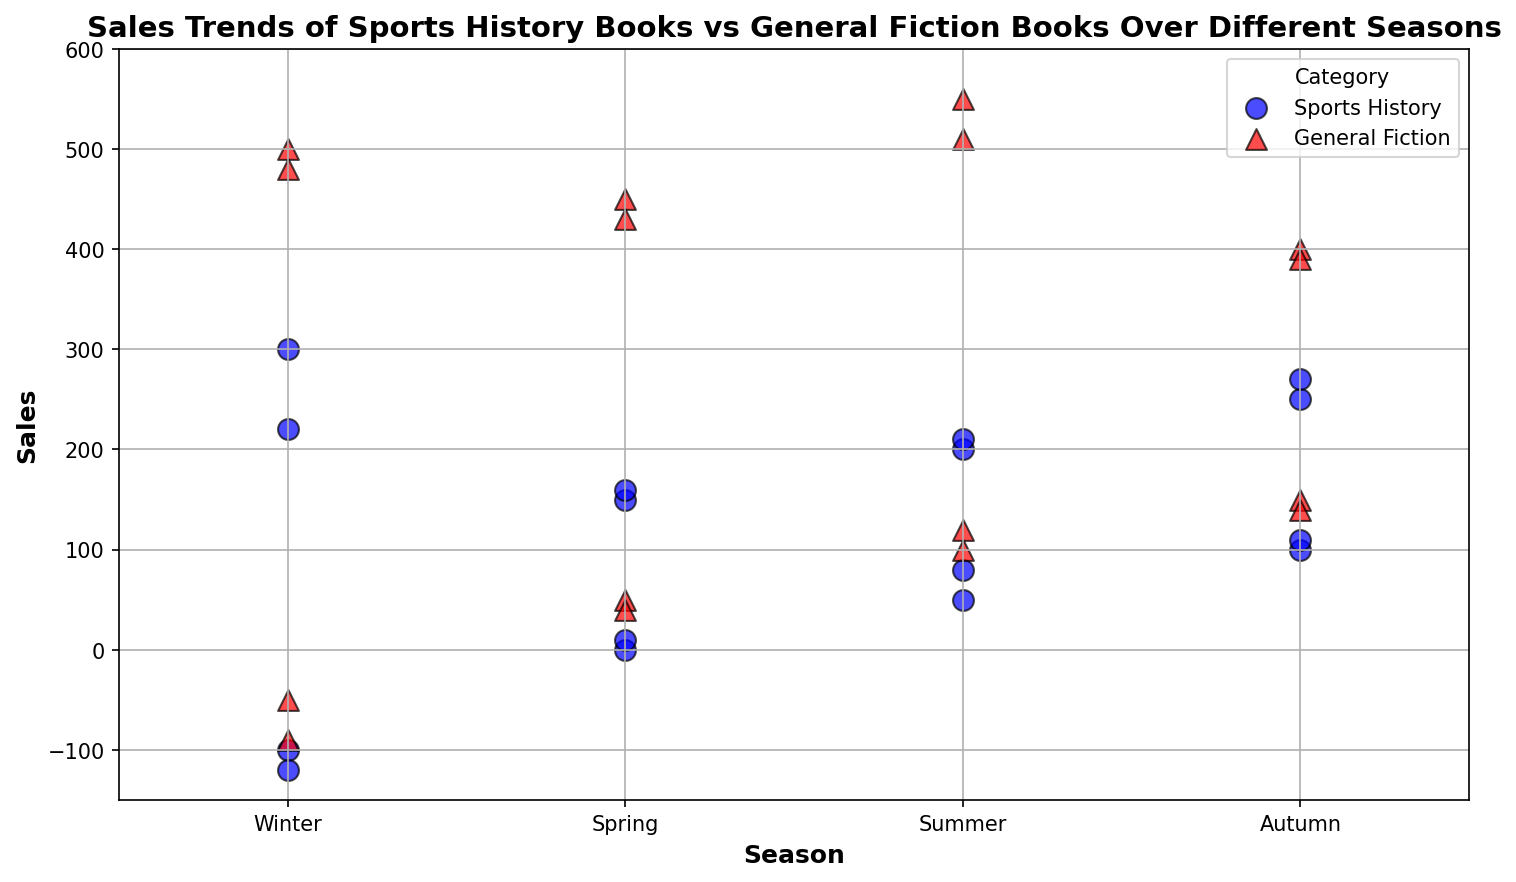What is the sales difference between Sports History and General Fiction books in Winter for the highest recorded sales? The highest recorded sales for Winter in Sports History is 300, and for General Fiction, it is 500. The difference is calculated as 500 - 300.
Answer: 200 In which season did Sports History books have the lowest non-negative sales, and what is that value? The non-negative sales values for Sports History are 0 (Spring), 50 (Summer), 100 (Autumn), and 10 (Spring). The lowest among these values is 0 in Spring.
Answer: Spring, 0 How do the sales of Sports History books in the Summer compare to those in Autumn for the lowest recorded positive sales in each category? In Summer, the lowest positive sales for Sports History is 50, and in Autumn, it's 100. Comparing the two, Summer has lower sales.
Answer: Summer What is the average sales for General Fiction in Autumn? The sales values for General Fiction in Autumn are 400, 150, 390, and 140. Summing them up gives 1080. Dividing by 4 to find the average, we get 1080 / 4 = 270.
Answer: 270 